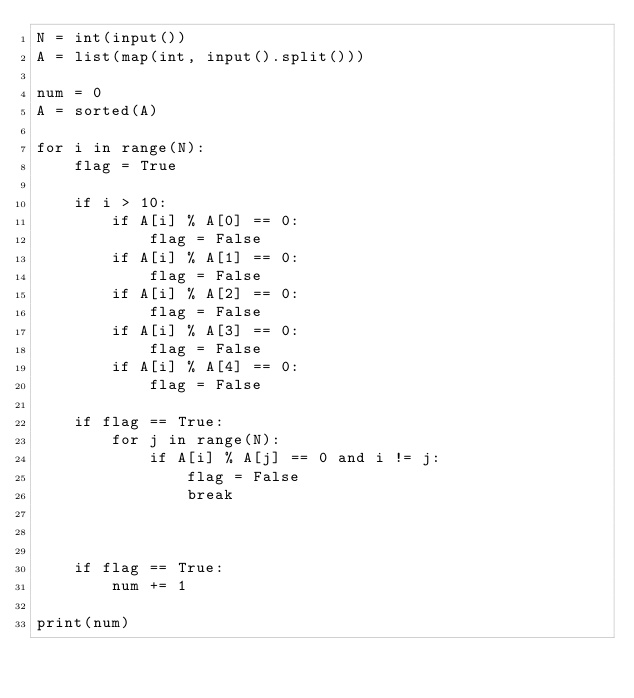<code> <loc_0><loc_0><loc_500><loc_500><_Python_>N = int(input())
A = list(map(int, input().split()))

num = 0
A = sorted(A)

for i in range(N):
    flag = True

    if i > 10:
        if A[i] % A[0] == 0:
            flag = False
        if A[i] % A[1] == 0:
            flag = False
        if A[i] % A[2] == 0:
            flag = False
        if A[i] % A[3] == 0:
            flag = False
        if A[i] % A[4] == 0:
            flag = False

    if flag == True:
        for j in range(N):
            if A[i] % A[j] == 0 and i != j:
                flag = False
                break



    if flag == True:
        num += 1

print(num)
</code> 